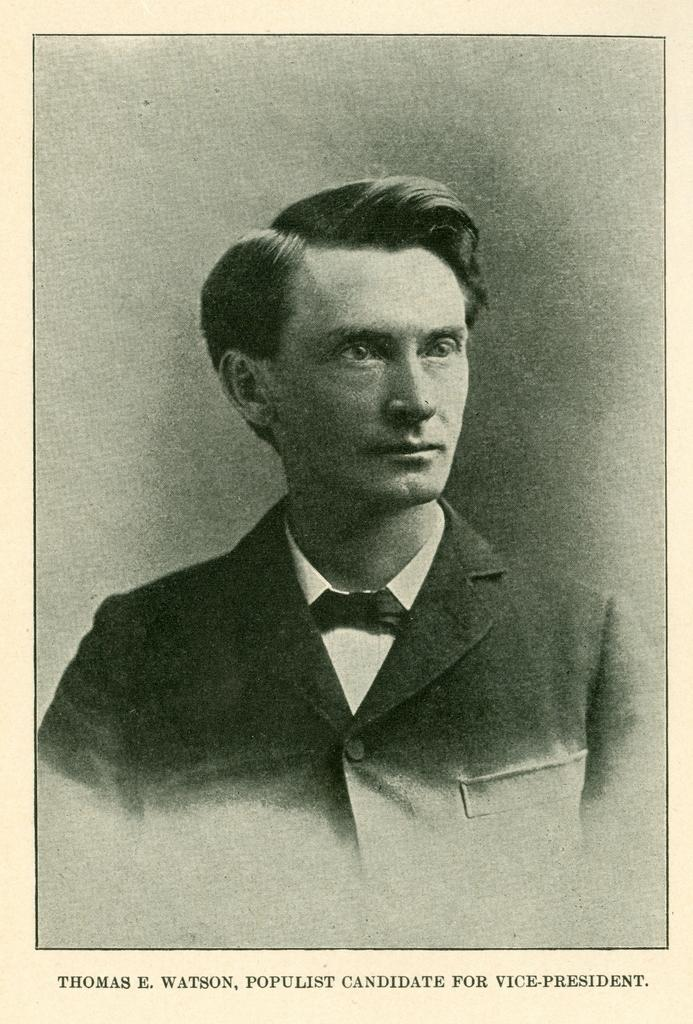What is depicted on the paper in the image? There is a man on the paper in the image. What is the man wearing in the image? The man is wearing a black color jacket in the image. How many chairs are present in the garden in the image? There is no garden or chairs present in the image; it only features a paper with a man wearing a black color jacket. 